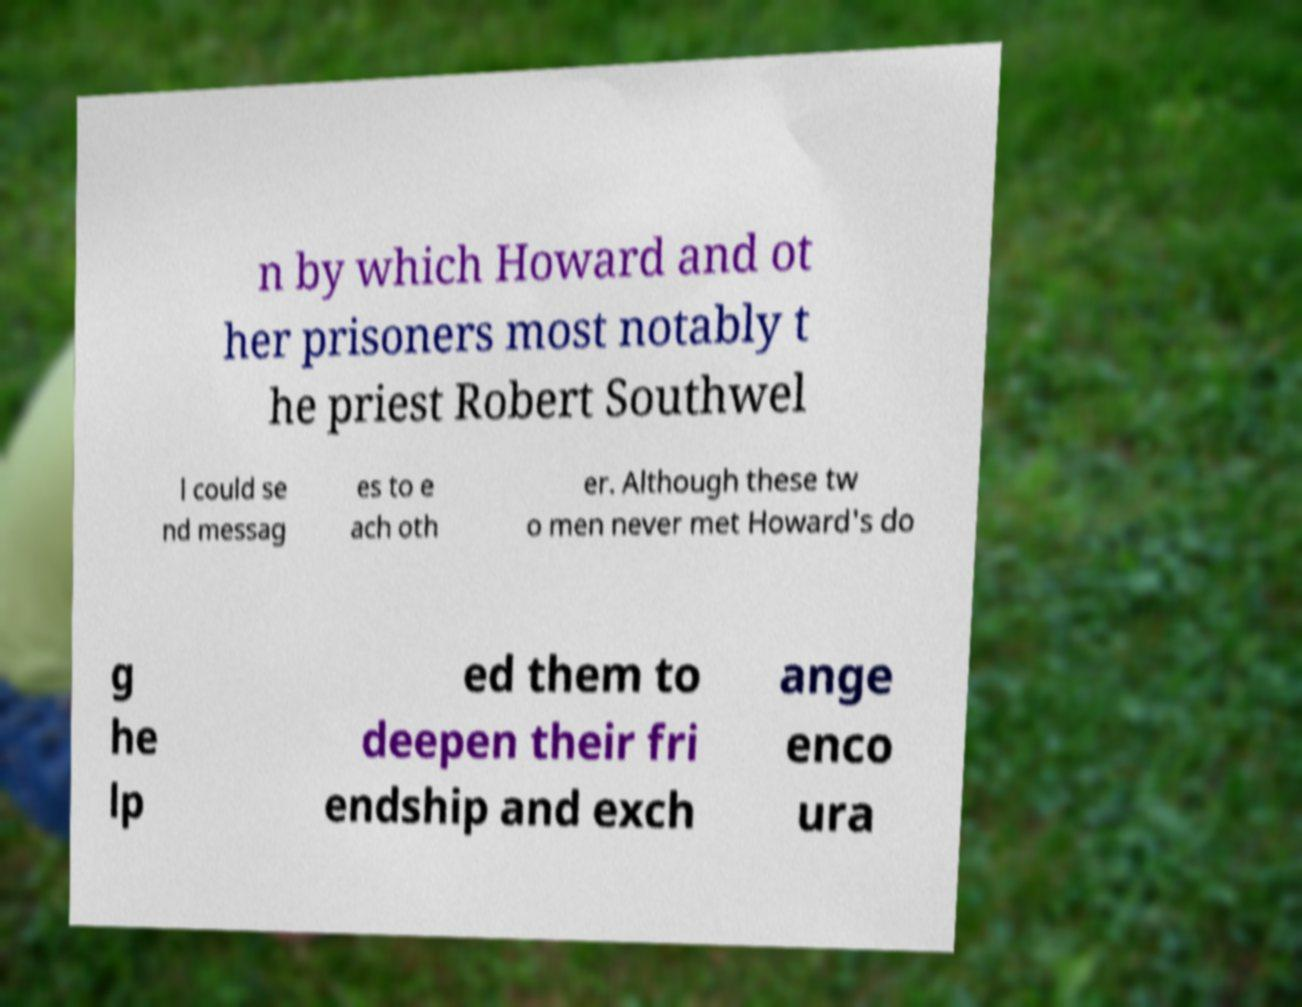There's text embedded in this image that I need extracted. Can you transcribe it verbatim? n by which Howard and ot her prisoners most notably t he priest Robert Southwel l could se nd messag es to e ach oth er. Although these tw o men never met Howard's do g he lp ed them to deepen their fri endship and exch ange enco ura 